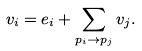<formula> <loc_0><loc_0><loc_500><loc_500>v _ { i } = e _ { i } + \sum _ { p _ { i } \rightarrow p _ { j } } v _ { j } .</formula> 